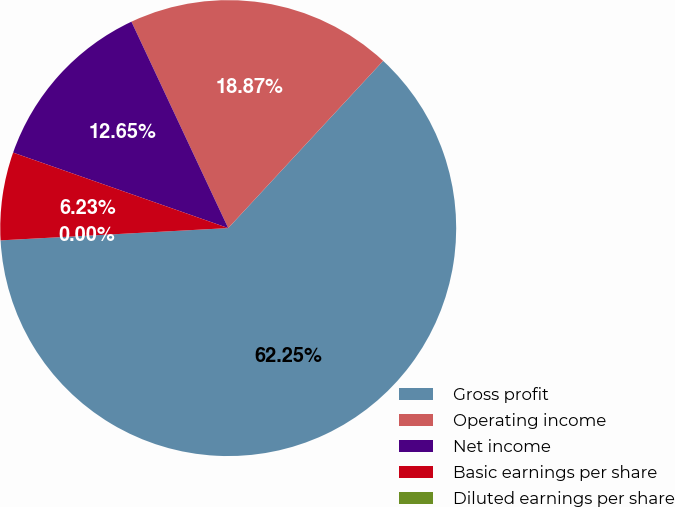Convert chart. <chart><loc_0><loc_0><loc_500><loc_500><pie_chart><fcel>Gross profit<fcel>Operating income<fcel>Net income<fcel>Basic earnings per share<fcel>Diluted earnings per share<nl><fcel>62.25%<fcel>18.87%<fcel>12.65%<fcel>6.23%<fcel>0.0%<nl></chart> 